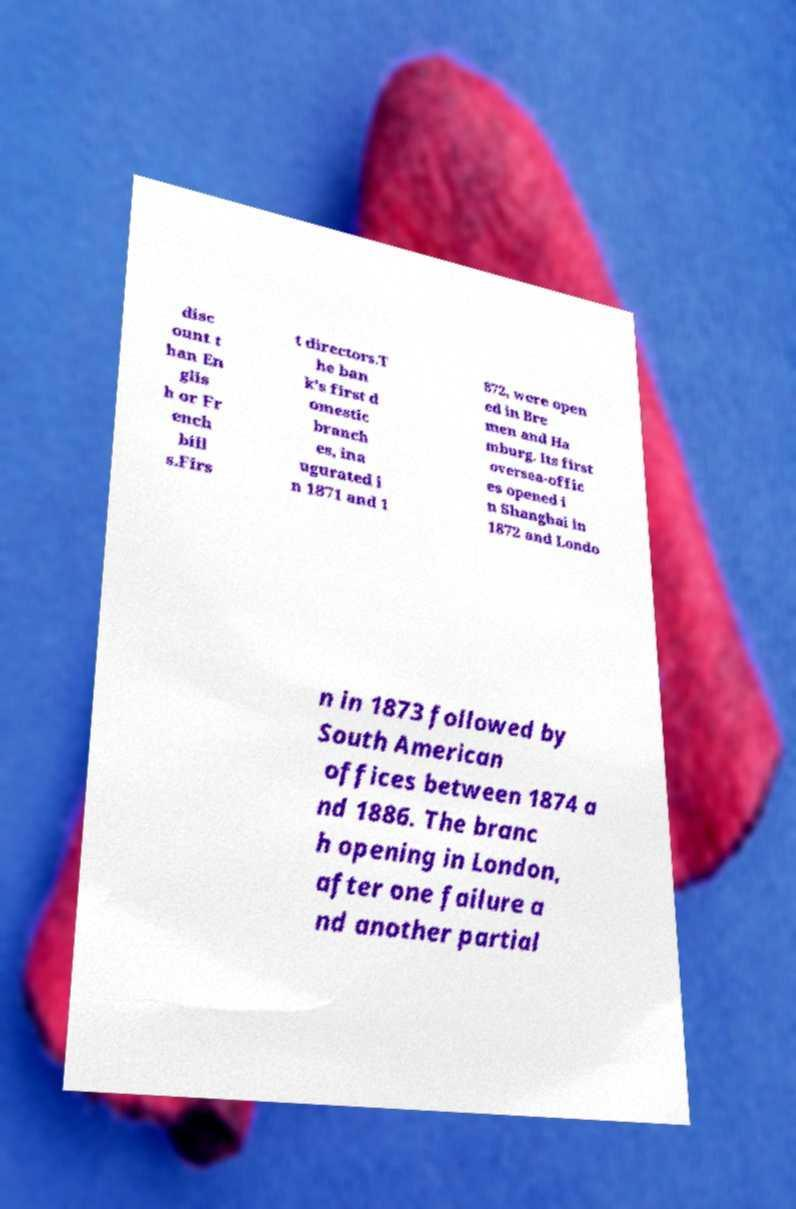Please identify and transcribe the text found in this image. disc ount t han En glis h or Fr ench bill s.Firs t directors.T he ban k's first d omestic branch es, ina ugurated i n 1871 and 1 872, were open ed in Bre men and Ha mburg. Its first oversea-offic es opened i n Shanghai in 1872 and Londo n in 1873 followed by South American offices between 1874 a nd 1886. The branc h opening in London, after one failure a nd another partial 